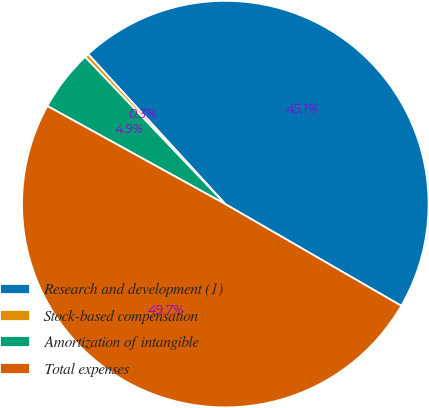<chart> <loc_0><loc_0><loc_500><loc_500><pie_chart><fcel>Research and development (1)<fcel>Stock-based compensation<fcel>Amortization of intangible<fcel>Total expenses<nl><fcel>45.13%<fcel>0.32%<fcel>4.87%<fcel>49.68%<nl></chart> 